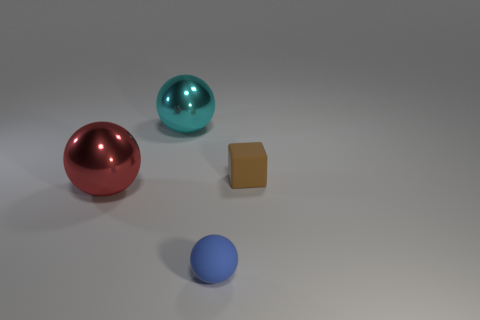Can you describe the lighting in the image? The lighting in the image is soft and diffused, creating gentle shadows on the right side of the objects, indicating the light source is coming from the left. This even lighting minimizes harsh shadows and allows the colors and shapes of the objects to be clearly seen. 